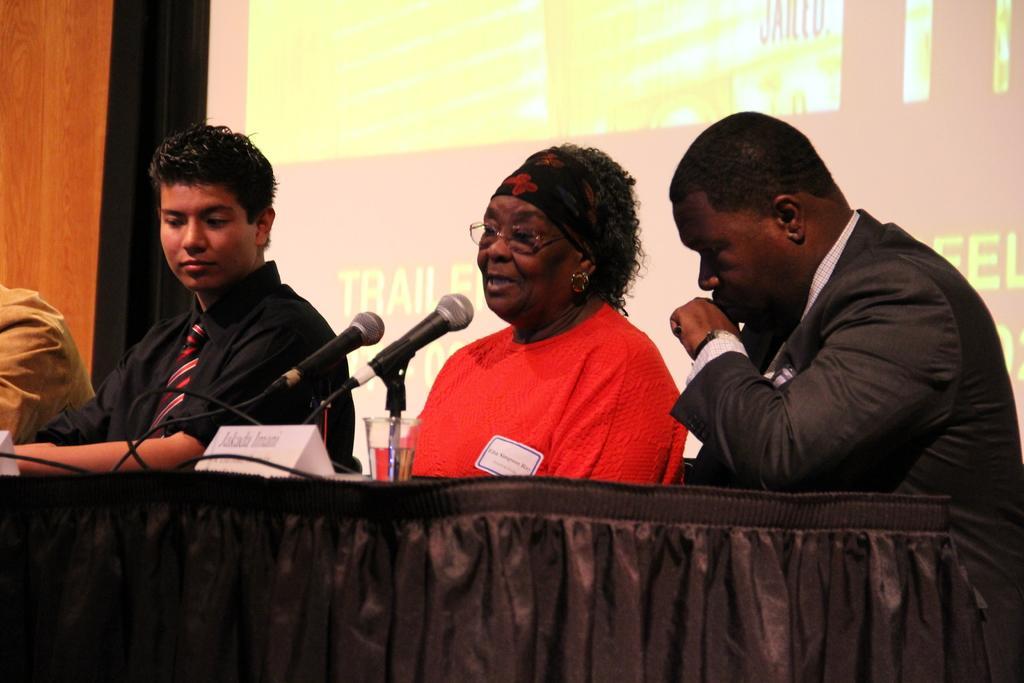Can you describe this image briefly? In the foreground of this image, there is a table and on which there is a glass, board and two mics and we can also see four people sitting. In the background, there is a screen and a wooden wall. 